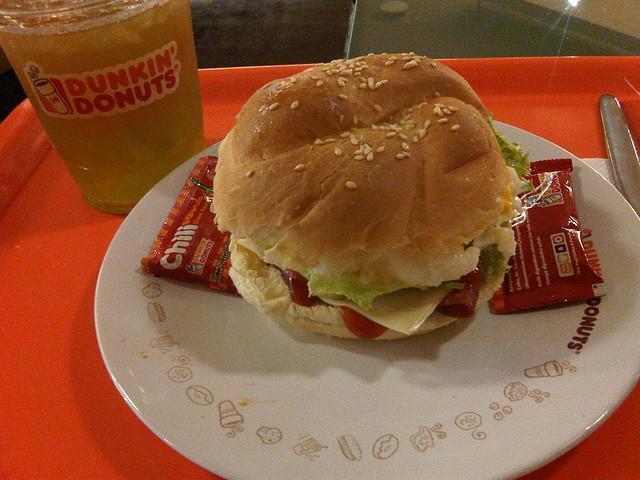How many bottles on table?
Give a very brief answer. 0. 